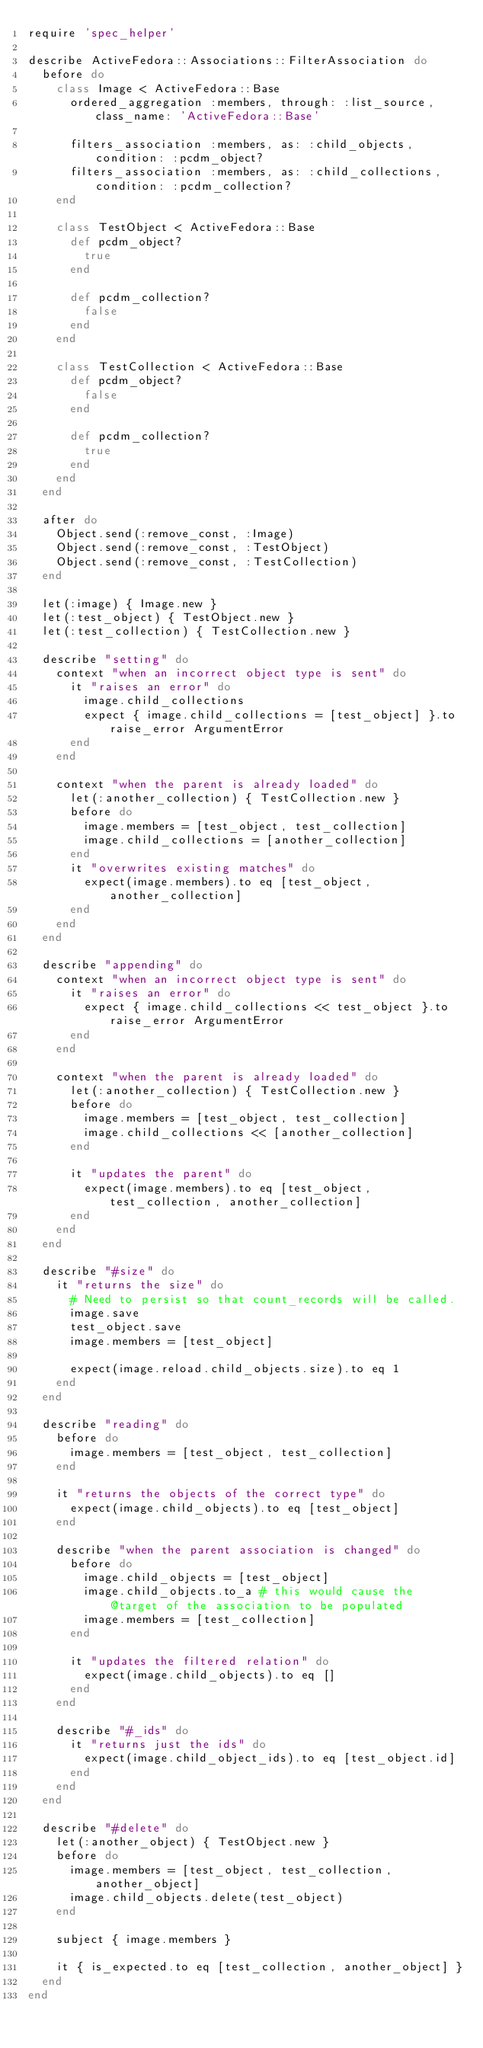Convert code to text. <code><loc_0><loc_0><loc_500><loc_500><_Ruby_>require 'spec_helper'

describe ActiveFedora::Associations::FilterAssociation do
  before do
    class Image < ActiveFedora::Base
      ordered_aggregation :members, through: :list_source, class_name: 'ActiveFedora::Base'

      filters_association :members, as: :child_objects, condition: :pcdm_object?
      filters_association :members, as: :child_collections, condition: :pcdm_collection?
    end

    class TestObject < ActiveFedora::Base
      def pcdm_object?
        true
      end

      def pcdm_collection?
        false
      end
    end

    class TestCollection < ActiveFedora::Base
      def pcdm_object?
        false
      end

      def pcdm_collection?
        true
      end
    end
  end

  after do
    Object.send(:remove_const, :Image)
    Object.send(:remove_const, :TestObject)
    Object.send(:remove_const, :TestCollection)
  end

  let(:image) { Image.new }
  let(:test_object) { TestObject.new }
  let(:test_collection) { TestCollection.new }

  describe "setting" do
    context "when an incorrect object type is sent" do
      it "raises an error" do
        image.child_collections
        expect { image.child_collections = [test_object] }.to raise_error ArgumentError
      end
    end

    context "when the parent is already loaded" do
      let(:another_collection) { TestCollection.new }
      before do
        image.members = [test_object, test_collection]
        image.child_collections = [another_collection]
      end
      it "overwrites existing matches" do
        expect(image.members).to eq [test_object, another_collection]
      end
    end
  end

  describe "appending" do
    context "when an incorrect object type is sent" do
      it "raises an error" do
        expect { image.child_collections << test_object }.to raise_error ArgumentError
      end
    end

    context "when the parent is already loaded" do
      let(:another_collection) { TestCollection.new }
      before do
        image.members = [test_object, test_collection]
        image.child_collections << [another_collection]
      end

      it "updates the parent" do
        expect(image.members).to eq [test_object, test_collection, another_collection]
      end
    end
  end

  describe "#size" do
    it "returns the size" do
      # Need to persist so that count_records will be called.
      image.save
      test_object.save
      image.members = [test_object]

      expect(image.reload.child_objects.size).to eq 1
    end
  end

  describe "reading" do
    before do
      image.members = [test_object, test_collection]
    end

    it "returns the objects of the correct type" do
      expect(image.child_objects).to eq [test_object]
    end

    describe "when the parent association is changed" do
      before do
        image.child_objects = [test_object]
        image.child_objects.to_a # this would cause the @target of the association to be populated
        image.members = [test_collection]
      end

      it "updates the filtered relation" do
        expect(image.child_objects).to eq []
      end
    end

    describe "#_ids" do
      it "returns just the ids" do
        expect(image.child_object_ids).to eq [test_object.id]
      end
    end
  end

  describe "#delete" do
    let(:another_object) { TestObject.new }
    before do
      image.members = [test_object, test_collection, another_object]
      image.child_objects.delete(test_object)
    end

    subject { image.members }

    it { is_expected.to eq [test_collection, another_object] }
  end
end
</code> 